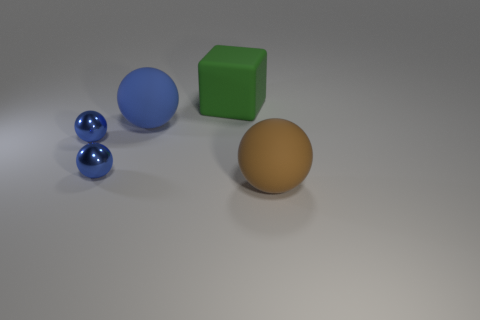Are there fewer large brown matte spheres than small red cylinders?
Offer a very short reply. No. There is a big thing that is both in front of the large green cube and behind the large brown thing; what material is it?
Your response must be concise. Rubber. What size is the object behind the large sphere that is behind the rubber sphere to the right of the large rubber block?
Your answer should be compact. Large. There is a big brown thing; is it the same shape as the rubber thing that is behind the blue matte thing?
Give a very brief answer. No. How many matte balls are both behind the brown rubber object and to the right of the rubber cube?
Your answer should be compact. 0. What number of green things are matte blocks or large rubber objects?
Make the answer very short. 1. There is a large object that is in front of the rubber sphere behind the big matte ball that is in front of the big blue matte sphere; what is its color?
Give a very brief answer. Brown. There is a brown object that is to the right of the big blue sphere; is there a sphere to the left of it?
Make the answer very short. Yes. Do the large object that is on the left side of the green matte object and the green object have the same shape?
Provide a short and direct response. No. Is there anything else that has the same shape as the large blue rubber thing?
Give a very brief answer. Yes. 